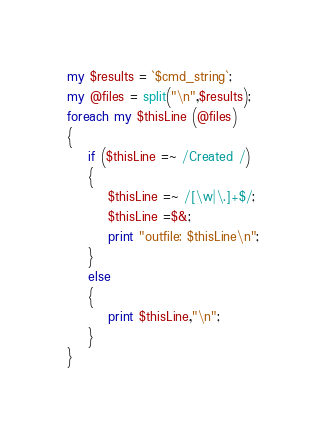Convert code to text. <code><loc_0><loc_0><loc_500><loc_500><_Perl_>my $results = `$cmd_string`;
my @files = split("\n",$results);
foreach my $thisLine (@files)
{
	if ($thisLine =~ /Created /)
	{
		$thisLine =~ /[\w|\.]+$/;
		$thisLine =$&;
		print "outfile: $thisLine\n";
	}
	else
	{
		print $thisLine,"\n";
	}
}
</code> 